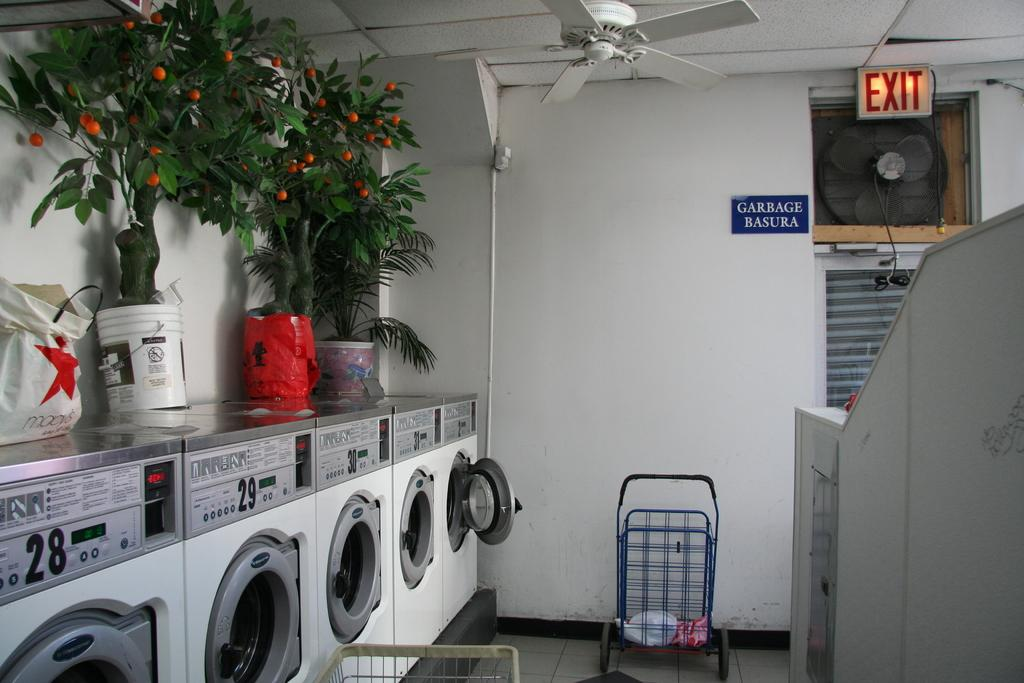<image>
Write a terse but informative summary of the picture. A few machines with the numbers 28 through 32 